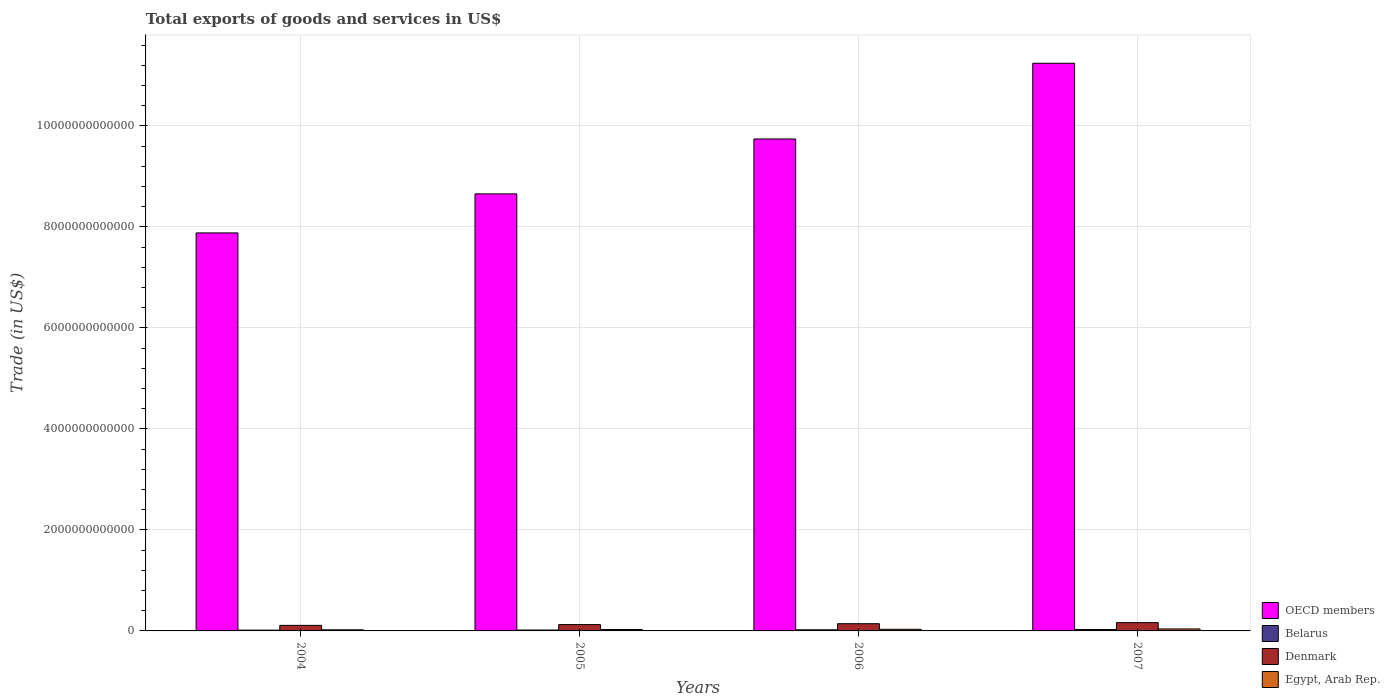How many groups of bars are there?
Offer a terse response. 4. Are the number of bars on each tick of the X-axis equal?
Your answer should be very brief. Yes. How many bars are there on the 2nd tick from the left?
Keep it short and to the point. 4. What is the total exports of goods and services in Egypt, Arab Rep. in 2006?
Offer a very short reply. 3.22e+1. Across all years, what is the maximum total exports of goods and services in Belarus?
Your response must be concise. 2.76e+1. Across all years, what is the minimum total exports of goods and services in Belarus?
Provide a succinct answer. 1.57e+1. In which year was the total exports of goods and services in Denmark maximum?
Provide a succinct answer. 2007. What is the total total exports of goods and services in Denmark in the graph?
Offer a very short reply. 5.42e+11. What is the difference between the total exports of goods and services in Belarus in 2005 and that in 2007?
Provide a short and direct response. -9.53e+09. What is the difference between the total exports of goods and services in Belarus in 2007 and the total exports of goods and services in Denmark in 2006?
Your response must be concise. -1.15e+11. What is the average total exports of goods and services in Belarus per year?
Provide a short and direct response. 2.09e+1. In the year 2004, what is the difference between the total exports of goods and services in OECD members and total exports of goods and services in Denmark?
Your answer should be compact. 7.77e+12. What is the ratio of the total exports of goods and services in OECD members in 2004 to that in 2005?
Offer a very short reply. 0.91. Is the difference between the total exports of goods and services in OECD members in 2005 and 2007 greater than the difference between the total exports of goods and services in Denmark in 2005 and 2007?
Your answer should be compact. No. What is the difference between the highest and the second highest total exports of goods and services in Egypt, Arab Rep.?
Your response must be concise. 7.28e+09. What is the difference between the highest and the lowest total exports of goods and services in OECD members?
Give a very brief answer. 3.36e+12. Is the sum of the total exports of goods and services in Denmark in 2005 and 2006 greater than the maximum total exports of goods and services in Egypt, Arab Rep. across all years?
Keep it short and to the point. Yes. What does the 4th bar from the right in 2005 represents?
Keep it short and to the point. OECD members. How many years are there in the graph?
Keep it short and to the point. 4. What is the difference between two consecutive major ticks on the Y-axis?
Offer a terse response. 2.00e+12. Are the values on the major ticks of Y-axis written in scientific E-notation?
Your response must be concise. No. Does the graph contain any zero values?
Give a very brief answer. No. Does the graph contain grids?
Your response must be concise. Yes. How many legend labels are there?
Offer a very short reply. 4. What is the title of the graph?
Keep it short and to the point. Total exports of goods and services in US$. What is the label or title of the Y-axis?
Keep it short and to the point. Trade (in US$). What is the Trade (in US$) in OECD members in 2004?
Your response must be concise. 7.88e+12. What is the Trade (in US$) of Belarus in 2004?
Offer a terse response. 1.57e+1. What is the Trade (in US$) of Denmark in 2004?
Ensure brevity in your answer.  1.10e+11. What is the Trade (in US$) of Egypt, Arab Rep. in 2004?
Offer a terse response. 2.23e+1. What is the Trade (in US$) of OECD members in 2005?
Your response must be concise. 8.65e+12. What is the Trade (in US$) of Belarus in 2005?
Provide a short and direct response. 1.81e+1. What is the Trade (in US$) in Denmark in 2005?
Give a very brief answer. 1.25e+11. What is the Trade (in US$) of Egypt, Arab Rep. in 2005?
Provide a short and direct response. 2.72e+1. What is the Trade (in US$) in OECD members in 2006?
Provide a succinct answer. 9.74e+12. What is the Trade (in US$) in Belarus in 2006?
Your response must be concise. 2.22e+1. What is the Trade (in US$) of Denmark in 2006?
Offer a terse response. 1.43e+11. What is the Trade (in US$) of Egypt, Arab Rep. in 2006?
Your answer should be very brief. 3.22e+1. What is the Trade (in US$) of OECD members in 2007?
Your response must be concise. 1.12e+13. What is the Trade (in US$) in Belarus in 2007?
Offer a very short reply. 2.76e+1. What is the Trade (in US$) of Denmark in 2007?
Offer a terse response. 1.64e+11. What is the Trade (in US$) in Egypt, Arab Rep. in 2007?
Make the answer very short. 3.95e+1. Across all years, what is the maximum Trade (in US$) in OECD members?
Offer a very short reply. 1.12e+13. Across all years, what is the maximum Trade (in US$) of Belarus?
Provide a short and direct response. 2.76e+1. Across all years, what is the maximum Trade (in US$) in Denmark?
Your response must be concise. 1.64e+11. Across all years, what is the maximum Trade (in US$) in Egypt, Arab Rep.?
Provide a succinct answer. 3.95e+1. Across all years, what is the minimum Trade (in US$) in OECD members?
Your response must be concise. 7.88e+12. Across all years, what is the minimum Trade (in US$) in Belarus?
Your answer should be very brief. 1.57e+1. Across all years, what is the minimum Trade (in US$) in Denmark?
Ensure brevity in your answer.  1.10e+11. Across all years, what is the minimum Trade (in US$) of Egypt, Arab Rep.?
Your answer should be very brief. 2.23e+1. What is the total Trade (in US$) in OECD members in the graph?
Your answer should be very brief. 3.75e+13. What is the total Trade (in US$) of Belarus in the graph?
Provide a short and direct response. 8.36e+1. What is the total Trade (in US$) of Denmark in the graph?
Offer a terse response. 5.42e+11. What is the total Trade (in US$) in Egypt, Arab Rep. in the graph?
Provide a succinct answer. 1.21e+11. What is the difference between the Trade (in US$) of OECD members in 2004 and that in 2005?
Provide a short and direct response. -7.73e+11. What is the difference between the Trade (in US$) of Belarus in 2004 and that in 2005?
Give a very brief answer. -2.35e+09. What is the difference between the Trade (in US$) of Denmark in 2004 and that in 2005?
Your answer should be very brief. -1.53e+1. What is the difference between the Trade (in US$) in Egypt, Arab Rep. in 2004 and that in 2005?
Offer a terse response. -4.96e+09. What is the difference between the Trade (in US$) of OECD members in 2004 and that in 2006?
Your answer should be compact. -1.86e+12. What is the difference between the Trade (in US$) of Belarus in 2004 and that in 2006?
Ensure brevity in your answer.  -6.49e+09. What is the difference between the Trade (in US$) in Denmark in 2004 and that in 2006?
Keep it short and to the point. -3.29e+1. What is the difference between the Trade (in US$) of Egypt, Arab Rep. in 2004 and that in 2006?
Keep it short and to the point. -9.93e+09. What is the difference between the Trade (in US$) in OECD members in 2004 and that in 2007?
Your response must be concise. -3.36e+12. What is the difference between the Trade (in US$) in Belarus in 2004 and that in 2007?
Keep it short and to the point. -1.19e+1. What is the difference between the Trade (in US$) of Denmark in 2004 and that in 2007?
Your response must be concise. -5.40e+1. What is the difference between the Trade (in US$) of Egypt, Arab Rep. in 2004 and that in 2007?
Your response must be concise. -1.72e+1. What is the difference between the Trade (in US$) in OECD members in 2005 and that in 2006?
Offer a very short reply. -1.09e+12. What is the difference between the Trade (in US$) in Belarus in 2005 and that in 2006?
Your response must be concise. -4.13e+09. What is the difference between the Trade (in US$) of Denmark in 2005 and that in 2006?
Provide a short and direct response. -1.76e+1. What is the difference between the Trade (in US$) in Egypt, Arab Rep. in 2005 and that in 2006?
Ensure brevity in your answer.  -4.98e+09. What is the difference between the Trade (in US$) in OECD members in 2005 and that in 2007?
Offer a very short reply. -2.59e+12. What is the difference between the Trade (in US$) in Belarus in 2005 and that in 2007?
Ensure brevity in your answer.  -9.53e+09. What is the difference between the Trade (in US$) of Denmark in 2005 and that in 2007?
Offer a terse response. -3.86e+1. What is the difference between the Trade (in US$) in Egypt, Arab Rep. in 2005 and that in 2007?
Offer a terse response. -1.23e+1. What is the difference between the Trade (in US$) of OECD members in 2006 and that in 2007?
Offer a terse response. -1.50e+12. What is the difference between the Trade (in US$) of Belarus in 2006 and that in 2007?
Keep it short and to the point. -5.39e+09. What is the difference between the Trade (in US$) of Denmark in 2006 and that in 2007?
Offer a very short reply. -2.10e+1. What is the difference between the Trade (in US$) in Egypt, Arab Rep. in 2006 and that in 2007?
Give a very brief answer. -7.28e+09. What is the difference between the Trade (in US$) of OECD members in 2004 and the Trade (in US$) of Belarus in 2005?
Keep it short and to the point. 7.86e+12. What is the difference between the Trade (in US$) of OECD members in 2004 and the Trade (in US$) of Denmark in 2005?
Provide a succinct answer. 7.76e+12. What is the difference between the Trade (in US$) of OECD members in 2004 and the Trade (in US$) of Egypt, Arab Rep. in 2005?
Give a very brief answer. 7.85e+12. What is the difference between the Trade (in US$) in Belarus in 2004 and the Trade (in US$) in Denmark in 2005?
Your answer should be compact. -1.10e+11. What is the difference between the Trade (in US$) of Belarus in 2004 and the Trade (in US$) of Egypt, Arab Rep. in 2005?
Give a very brief answer. -1.15e+1. What is the difference between the Trade (in US$) in Denmark in 2004 and the Trade (in US$) in Egypt, Arab Rep. in 2005?
Your answer should be compact. 8.28e+1. What is the difference between the Trade (in US$) of OECD members in 2004 and the Trade (in US$) of Belarus in 2006?
Your answer should be very brief. 7.86e+12. What is the difference between the Trade (in US$) of OECD members in 2004 and the Trade (in US$) of Denmark in 2006?
Provide a succinct answer. 7.74e+12. What is the difference between the Trade (in US$) of OECD members in 2004 and the Trade (in US$) of Egypt, Arab Rep. in 2006?
Make the answer very short. 7.85e+12. What is the difference between the Trade (in US$) of Belarus in 2004 and the Trade (in US$) of Denmark in 2006?
Your answer should be very brief. -1.27e+11. What is the difference between the Trade (in US$) of Belarus in 2004 and the Trade (in US$) of Egypt, Arab Rep. in 2006?
Keep it short and to the point. -1.65e+1. What is the difference between the Trade (in US$) of Denmark in 2004 and the Trade (in US$) of Egypt, Arab Rep. in 2006?
Provide a short and direct response. 7.79e+1. What is the difference between the Trade (in US$) in OECD members in 2004 and the Trade (in US$) in Belarus in 2007?
Your answer should be compact. 7.85e+12. What is the difference between the Trade (in US$) of OECD members in 2004 and the Trade (in US$) of Denmark in 2007?
Provide a succinct answer. 7.72e+12. What is the difference between the Trade (in US$) in OECD members in 2004 and the Trade (in US$) in Egypt, Arab Rep. in 2007?
Offer a terse response. 7.84e+12. What is the difference between the Trade (in US$) of Belarus in 2004 and the Trade (in US$) of Denmark in 2007?
Your answer should be very brief. -1.48e+11. What is the difference between the Trade (in US$) of Belarus in 2004 and the Trade (in US$) of Egypt, Arab Rep. in 2007?
Keep it short and to the point. -2.38e+1. What is the difference between the Trade (in US$) in Denmark in 2004 and the Trade (in US$) in Egypt, Arab Rep. in 2007?
Keep it short and to the point. 7.06e+1. What is the difference between the Trade (in US$) in OECD members in 2005 and the Trade (in US$) in Belarus in 2006?
Make the answer very short. 8.63e+12. What is the difference between the Trade (in US$) of OECD members in 2005 and the Trade (in US$) of Denmark in 2006?
Ensure brevity in your answer.  8.51e+12. What is the difference between the Trade (in US$) of OECD members in 2005 and the Trade (in US$) of Egypt, Arab Rep. in 2006?
Provide a short and direct response. 8.62e+12. What is the difference between the Trade (in US$) in Belarus in 2005 and the Trade (in US$) in Denmark in 2006?
Your response must be concise. -1.25e+11. What is the difference between the Trade (in US$) in Belarus in 2005 and the Trade (in US$) in Egypt, Arab Rep. in 2006?
Make the answer very short. -1.41e+1. What is the difference between the Trade (in US$) in Denmark in 2005 and the Trade (in US$) in Egypt, Arab Rep. in 2006?
Provide a short and direct response. 9.32e+1. What is the difference between the Trade (in US$) of OECD members in 2005 and the Trade (in US$) of Belarus in 2007?
Offer a terse response. 8.63e+12. What is the difference between the Trade (in US$) in OECD members in 2005 and the Trade (in US$) in Denmark in 2007?
Offer a very short reply. 8.49e+12. What is the difference between the Trade (in US$) in OECD members in 2005 and the Trade (in US$) in Egypt, Arab Rep. in 2007?
Make the answer very short. 8.61e+12. What is the difference between the Trade (in US$) in Belarus in 2005 and the Trade (in US$) in Denmark in 2007?
Give a very brief answer. -1.46e+11. What is the difference between the Trade (in US$) of Belarus in 2005 and the Trade (in US$) of Egypt, Arab Rep. in 2007?
Offer a terse response. -2.14e+1. What is the difference between the Trade (in US$) of Denmark in 2005 and the Trade (in US$) of Egypt, Arab Rep. in 2007?
Keep it short and to the point. 8.59e+1. What is the difference between the Trade (in US$) in OECD members in 2006 and the Trade (in US$) in Belarus in 2007?
Offer a terse response. 9.71e+12. What is the difference between the Trade (in US$) in OECD members in 2006 and the Trade (in US$) in Denmark in 2007?
Keep it short and to the point. 9.58e+12. What is the difference between the Trade (in US$) of OECD members in 2006 and the Trade (in US$) of Egypt, Arab Rep. in 2007?
Keep it short and to the point. 9.70e+12. What is the difference between the Trade (in US$) in Belarus in 2006 and the Trade (in US$) in Denmark in 2007?
Your response must be concise. -1.42e+11. What is the difference between the Trade (in US$) in Belarus in 2006 and the Trade (in US$) in Egypt, Arab Rep. in 2007?
Offer a terse response. -1.73e+1. What is the difference between the Trade (in US$) of Denmark in 2006 and the Trade (in US$) of Egypt, Arab Rep. in 2007?
Your answer should be very brief. 1.04e+11. What is the average Trade (in US$) in OECD members per year?
Your response must be concise. 9.38e+12. What is the average Trade (in US$) of Belarus per year?
Your answer should be very brief. 2.09e+1. What is the average Trade (in US$) in Denmark per year?
Offer a very short reply. 1.36e+11. What is the average Trade (in US$) of Egypt, Arab Rep. per year?
Your response must be concise. 3.03e+1. In the year 2004, what is the difference between the Trade (in US$) in OECD members and Trade (in US$) in Belarus?
Ensure brevity in your answer.  7.86e+12. In the year 2004, what is the difference between the Trade (in US$) of OECD members and Trade (in US$) of Denmark?
Offer a very short reply. 7.77e+12. In the year 2004, what is the difference between the Trade (in US$) of OECD members and Trade (in US$) of Egypt, Arab Rep.?
Ensure brevity in your answer.  7.86e+12. In the year 2004, what is the difference between the Trade (in US$) in Belarus and Trade (in US$) in Denmark?
Provide a short and direct response. -9.43e+1. In the year 2004, what is the difference between the Trade (in US$) of Belarus and Trade (in US$) of Egypt, Arab Rep.?
Offer a very short reply. -6.55e+09. In the year 2004, what is the difference between the Trade (in US$) in Denmark and Trade (in US$) in Egypt, Arab Rep.?
Your answer should be compact. 8.78e+1. In the year 2005, what is the difference between the Trade (in US$) of OECD members and Trade (in US$) of Belarus?
Make the answer very short. 8.64e+12. In the year 2005, what is the difference between the Trade (in US$) of OECD members and Trade (in US$) of Denmark?
Your response must be concise. 8.53e+12. In the year 2005, what is the difference between the Trade (in US$) in OECD members and Trade (in US$) in Egypt, Arab Rep.?
Keep it short and to the point. 8.63e+12. In the year 2005, what is the difference between the Trade (in US$) of Belarus and Trade (in US$) of Denmark?
Provide a short and direct response. -1.07e+11. In the year 2005, what is the difference between the Trade (in US$) of Belarus and Trade (in US$) of Egypt, Arab Rep.?
Your answer should be compact. -9.15e+09. In the year 2005, what is the difference between the Trade (in US$) in Denmark and Trade (in US$) in Egypt, Arab Rep.?
Offer a very short reply. 9.82e+1. In the year 2006, what is the difference between the Trade (in US$) of OECD members and Trade (in US$) of Belarus?
Ensure brevity in your answer.  9.72e+12. In the year 2006, what is the difference between the Trade (in US$) of OECD members and Trade (in US$) of Denmark?
Give a very brief answer. 9.60e+12. In the year 2006, what is the difference between the Trade (in US$) of OECD members and Trade (in US$) of Egypt, Arab Rep.?
Offer a very short reply. 9.71e+12. In the year 2006, what is the difference between the Trade (in US$) of Belarus and Trade (in US$) of Denmark?
Provide a short and direct response. -1.21e+11. In the year 2006, what is the difference between the Trade (in US$) of Belarus and Trade (in US$) of Egypt, Arab Rep.?
Your answer should be very brief. -9.99e+09. In the year 2006, what is the difference between the Trade (in US$) of Denmark and Trade (in US$) of Egypt, Arab Rep.?
Keep it short and to the point. 1.11e+11. In the year 2007, what is the difference between the Trade (in US$) in OECD members and Trade (in US$) in Belarus?
Your response must be concise. 1.12e+13. In the year 2007, what is the difference between the Trade (in US$) of OECD members and Trade (in US$) of Denmark?
Provide a short and direct response. 1.11e+13. In the year 2007, what is the difference between the Trade (in US$) of OECD members and Trade (in US$) of Egypt, Arab Rep.?
Offer a very short reply. 1.12e+13. In the year 2007, what is the difference between the Trade (in US$) in Belarus and Trade (in US$) in Denmark?
Your response must be concise. -1.36e+11. In the year 2007, what is the difference between the Trade (in US$) of Belarus and Trade (in US$) of Egypt, Arab Rep.?
Provide a succinct answer. -1.19e+1. In the year 2007, what is the difference between the Trade (in US$) in Denmark and Trade (in US$) in Egypt, Arab Rep.?
Keep it short and to the point. 1.25e+11. What is the ratio of the Trade (in US$) in OECD members in 2004 to that in 2005?
Ensure brevity in your answer.  0.91. What is the ratio of the Trade (in US$) in Belarus in 2004 to that in 2005?
Your answer should be very brief. 0.87. What is the ratio of the Trade (in US$) of Denmark in 2004 to that in 2005?
Give a very brief answer. 0.88. What is the ratio of the Trade (in US$) in Egypt, Arab Rep. in 2004 to that in 2005?
Your answer should be compact. 0.82. What is the ratio of the Trade (in US$) of OECD members in 2004 to that in 2006?
Provide a short and direct response. 0.81. What is the ratio of the Trade (in US$) in Belarus in 2004 to that in 2006?
Provide a succinct answer. 0.71. What is the ratio of the Trade (in US$) in Denmark in 2004 to that in 2006?
Provide a short and direct response. 0.77. What is the ratio of the Trade (in US$) in Egypt, Arab Rep. in 2004 to that in 2006?
Your answer should be very brief. 0.69. What is the ratio of the Trade (in US$) of OECD members in 2004 to that in 2007?
Offer a very short reply. 0.7. What is the ratio of the Trade (in US$) in Belarus in 2004 to that in 2007?
Offer a terse response. 0.57. What is the ratio of the Trade (in US$) in Denmark in 2004 to that in 2007?
Your answer should be very brief. 0.67. What is the ratio of the Trade (in US$) in Egypt, Arab Rep. in 2004 to that in 2007?
Make the answer very short. 0.56. What is the ratio of the Trade (in US$) in OECD members in 2005 to that in 2006?
Give a very brief answer. 0.89. What is the ratio of the Trade (in US$) of Belarus in 2005 to that in 2006?
Provide a succinct answer. 0.81. What is the ratio of the Trade (in US$) of Denmark in 2005 to that in 2006?
Make the answer very short. 0.88. What is the ratio of the Trade (in US$) of Egypt, Arab Rep. in 2005 to that in 2006?
Your answer should be compact. 0.85. What is the ratio of the Trade (in US$) in OECD members in 2005 to that in 2007?
Provide a succinct answer. 0.77. What is the ratio of the Trade (in US$) of Belarus in 2005 to that in 2007?
Your answer should be very brief. 0.65. What is the ratio of the Trade (in US$) in Denmark in 2005 to that in 2007?
Keep it short and to the point. 0.76. What is the ratio of the Trade (in US$) in Egypt, Arab Rep. in 2005 to that in 2007?
Give a very brief answer. 0.69. What is the ratio of the Trade (in US$) of OECD members in 2006 to that in 2007?
Your response must be concise. 0.87. What is the ratio of the Trade (in US$) in Belarus in 2006 to that in 2007?
Your answer should be very brief. 0.8. What is the ratio of the Trade (in US$) in Denmark in 2006 to that in 2007?
Provide a short and direct response. 0.87. What is the ratio of the Trade (in US$) in Egypt, Arab Rep. in 2006 to that in 2007?
Provide a short and direct response. 0.82. What is the difference between the highest and the second highest Trade (in US$) of OECD members?
Provide a succinct answer. 1.50e+12. What is the difference between the highest and the second highest Trade (in US$) of Belarus?
Offer a terse response. 5.39e+09. What is the difference between the highest and the second highest Trade (in US$) of Denmark?
Your response must be concise. 2.10e+1. What is the difference between the highest and the second highest Trade (in US$) in Egypt, Arab Rep.?
Ensure brevity in your answer.  7.28e+09. What is the difference between the highest and the lowest Trade (in US$) in OECD members?
Make the answer very short. 3.36e+12. What is the difference between the highest and the lowest Trade (in US$) in Belarus?
Offer a terse response. 1.19e+1. What is the difference between the highest and the lowest Trade (in US$) in Denmark?
Offer a terse response. 5.40e+1. What is the difference between the highest and the lowest Trade (in US$) of Egypt, Arab Rep.?
Offer a very short reply. 1.72e+1. 